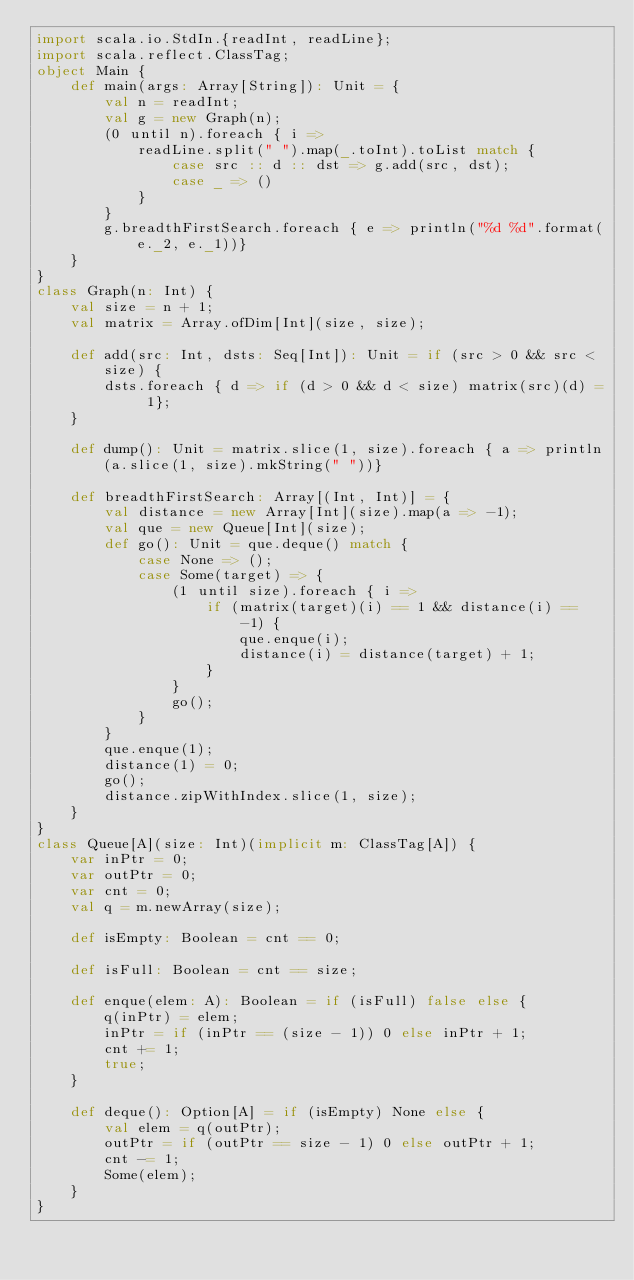<code> <loc_0><loc_0><loc_500><loc_500><_Scala_>import scala.io.StdIn.{readInt, readLine};
import scala.reflect.ClassTag;
object Main {
    def main(args: Array[String]): Unit = {
        val n = readInt;
        val g = new Graph(n);
        (0 until n).foreach { i => 
            readLine.split(" ").map(_.toInt).toList match {
                case src :: d :: dst => g.add(src, dst);
                case _ => ()
            }
        }
        g.breadthFirstSearch.foreach { e => println("%d %d".format(e._2, e._1))}
    }
}
class Graph(n: Int) {
    val size = n + 1;
    val matrix = Array.ofDim[Int](size, size);
    
    def add(src: Int, dsts: Seq[Int]): Unit = if (src > 0 && src < size) {
        dsts.foreach { d => if (d > 0 && d < size) matrix(src)(d) = 1};
    }
    
    def dump(): Unit = matrix.slice(1, size).foreach { a => println(a.slice(1, size).mkString(" "))}
    
    def breadthFirstSearch: Array[(Int, Int)] = {
        val distance = new Array[Int](size).map(a => -1);
        val que = new Queue[Int](size);
        def go(): Unit = que.deque() match {
            case None => ();
            case Some(target) => {
                (1 until size).foreach { i =>
                    if (matrix(target)(i) == 1 && distance(i) == -1) {
                        que.enque(i);
                        distance(i) = distance(target) + 1;
                    }
                }
                go();
            }
        }
        que.enque(1);
        distance(1) = 0;
        go();
        distance.zipWithIndex.slice(1, size);
    }
}
class Queue[A](size: Int)(implicit m: ClassTag[A]) {
    var inPtr = 0;
    var outPtr = 0;
    var cnt = 0;
    val q = m.newArray(size);
    
    def isEmpty: Boolean = cnt == 0;
    
    def isFull: Boolean = cnt == size;
    
    def enque(elem: A): Boolean = if (isFull) false else {
        q(inPtr) = elem;
        inPtr = if (inPtr == (size - 1)) 0 else inPtr + 1;
        cnt += 1;
        true;
    }
    
    def deque(): Option[A] = if (isEmpty) None else {
        val elem = q(outPtr);
        outPtr = if (outPtr == size - 1) 0 else outPtr + 1;
        cnt -= 1;
        Some(elem);
    }
}
</code> 